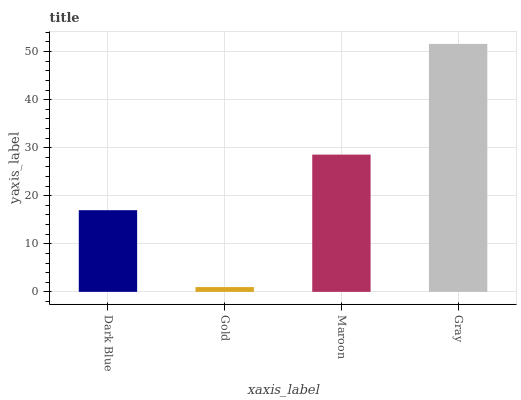Is Gold the minimum?
Answer yes or no. Yes. Is Gray the maximum?
Answer yes or no. Yes. Is Maroon the minimum?
Answer yes or no. No. Is Maroon the maximum?
Answer yes or no. No. Is Maroon greater than Gold?
Answer yes or no. Yes. Is Gold less than Maroon?
Answer yes or no. Yes. Is Gold greater than Maroon?
Answer yes or no. No. Is Maroon less than Gold?
Answer yes or no. No. Is Maroon the high median?
Answer yes or no. Yes. Is Dark Blue the low median?
Answer yes or no. Yes. Is Gray the high median?
Answer yes or no. No. Is Gold the low median?
Answer yes or no. No. 